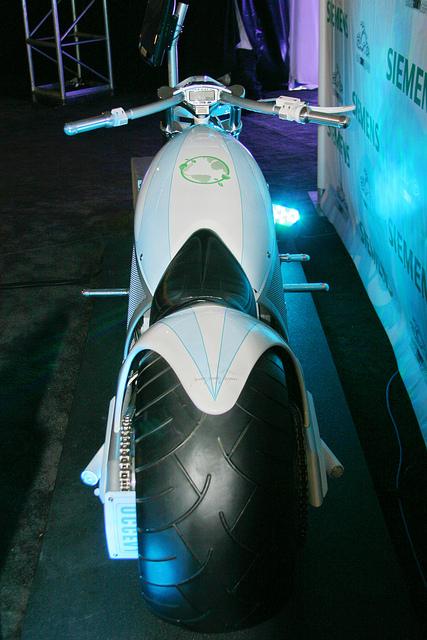How many tires are on this vehicle?
Quick response, please. 2. What colors are on the bike?
Answer briefly. White and black. Does this motorcycle need a new tire?
Give a very brief answer. No. 